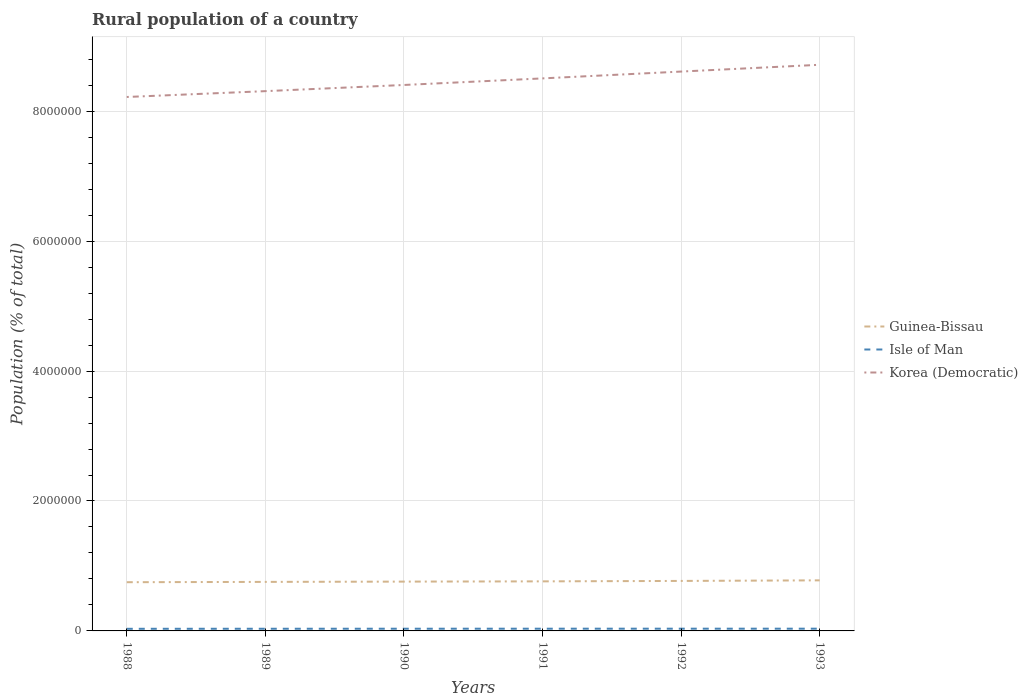How many different coloured lines are there?
Your answer should be very brief. 3. Is the number of lines equal to the number of legend labels?
Provide a succinct answer. Yes. Across all years, what is the maximum rural population in Guinea-Bissau?
Keep it short and to the point. 7.50e+05. What is the total rural population in Isle of Man in the graph?
Provide a succinct answer. -1722. What is the difference between the highest and the second highest rural population in Guinea-Bissau?
Make the answer very short. 2.86e+04. How many lines are there?
Give a very brief answer. 3. Does the graph contain any zero values?
Your response must be concise. No. Does the graph contain grids?
Ensure brevity in your answer.  Yes. Where does the legend appear in the graph?
Keep it short and to the point. Center right. How many legend labels are there?
Your answer should be compact. 3. How are the legend labels stacked?
Offer a terse response. Vertical. What is the title of the graph?
Your answer should be compact. Rural population of a country. What is the label or title of the Y-axis?
Your answer should be very brief. Population (% of total). What is the Population (% of total) of Guinea-Bissau in 1988?
Make the answer very short. 7.50e+05. What is the Population (% of total) in Isle of Man in 1988?
Give a very brief answer. 3.28e+04. What is the Population (% of total) in Korea (Democratic) in 1988?
Your answer should be compact. 8.22e+06. What is the Population (% of total) of Guinea-Bissau in 1989?
Offer a terse response. 7.55e+05. What is the Population (% of total) in Isle of Man in 1989?
Make the answer very short. 3.34e+04. What is the Population (% of total) of Korea (Democratic) in 1989?
Ensure brevity in your answer.  8.31e+06. What is the Population (% of total) in Guinea-Bissau in 1990?
Give a very brief answer. 7.59e+05. What is the Population (% of total) of Isle of Man in 1990?
Keep it short and to the point. 3.39e+04. What is the Population (% of total) of Korea (Democratic) in 1990?
Give a very brief answer. 8.40e+06. What is the Population (% of total) of Guinea-Bissau in 1991?
Keep it short and to the point. 7.63e+05. What is the Population (% of total) of Isle of Man in 1991?
Keep it short and to the point. 3.42e+04. What is the Population (% of total) of Korea (Democratic) in 1991?
Your answer should be very brief. 8.51e+06. What is the Population (% of total) of Guinea-Bissau in 1992?
Give a very brief answer. 7.70e+05. What is the Population (% of total) in Isle of Man in 1992?
Give a very brief answer. 3.44e+04. What is the Population (% of total) of Korea (Democratic) in 1992?
Ensure brevity in your answer.  8.61e+06. What is the Population (% of total) in Guinea-Bissau in 1993?
Give a very brief answer. 7.78e+05. What is the Population (% of total) of Isle of Man in 1993?
Keep it short and to the point. 3.45e+04. What is the Population (% of total) in Korea (Democratic) in 1993?
Offer a very short reply. 8.71e+06. Across all years, what is the maximum Population (% of total) in Guinea-Bissau?
Offer a terse response. 7.78e+05. Across all years, what is the maximum Population (% of total) in Isle of Man?
Provide a short and direct response. 3.45e+04. Across all years, what is the maximum Population (% of total) of Korea (Democratic)?
Provide a short and direct response. 8.71e+06. Across all years, what is the minimum Population (% of total) in Guinea-Bissau?
Keep it short and to the point. 7.50e+05. Across all years, what is the minimum Population (% of total) of Isle of Man?
Make the answer very short. 3.28e+04. Across all years, what is the minimum Population (% of total) in Korea (Democratic)?
Provide a short and direct response. 8.22e+06. What is the total Population (% of total) in Guinea-Bissau in the graph?
Provide a short and direct response. 4.57e+06. What is the total Population (% of total) of Isle of Man in the graph?
Your answer should be very brief. 2.03e+05. What is the total Population (% of total) in Korea (Democratic) in the graph?
Give a very brief answer. 5.08e+07. What is the difference between the Population (% of total) of Guinea-Bissau in 1988 and that in 1989?
Your answer should be compact. -4837. What is the difference between the Population (% of total) of Isle of Man in 1988 and that in 1989?
Your answer should be compact. -660. What is the difference between the Population (% of total) of Korea (Democratic) in 1988 and that in 1989?
Your answer should be very brief. -9.00e+04. What is the difference between the Population (% of total) in Guinea-Bissau in 1988 and that in 1990?
Ensure brevity in your answer.  -9186. What is the difference between the Population (% of total) of Isle of Man in 1988 and that in 1990?
Give a very brief answer. -1168. What is the difference between the Population (% of total) in Korea (Democratic) in 1988 and that in 1990?
Keep it short and to the point. -1.85e+05. What is the difference between the Population (% of total) in Guinea-Bissau in 1988 and that in 1991?
Offer a terse response. -1.30e+04. What is the difference between the Population (% of total) in Isle of Man in 1988 and that in 1991?
Offer a very short reply. -1483. What is the difference between the Population (% of total) of Korea (Democratic) in 1988 and that in 1991?
Offer a terse response. -2.86e+05. What is the difference between the Population (% of total) in Guinea-Bissau in 1988 and that in 1992?
Keep it short and to the point. -1.97e+04. What is the difference between the Population (% of total) in Isle of Man in 1988 and that in 1992?
Your response must be concise. -1642. What is the difference between the Population (% of total) of Korea (Democratic) in 1988 and that in 1992?
Offer a very short reply. -3.91e+05. What is the difference between the Population (% of total) in Guinea-Bissau in 1988 and that in 1993?
Ensure brevity in your answer.  -2.86e+04. What is the difference between the Population (% of total) in Isle of Man in 1988 and that in 1993?
Give a very brief answer. -1722. What is the difference between the Population (% of total) of Korea (Democratic) in 1988 and that in 1993?
Keep it short and to the point. -4.96e+05. What is the difference between the Population (% of total) of Guinea-Bissau in 1989 and that in 1990?
Your answer should be compact. -4349. What is the difference between the Population (% of total) of Isle of Man in 1989 and that in 1990?
Ensure brevity in your answer.  -508. What is the difference between the Population (% of total) in Korea (Democratic) in 1989 and that in 1990?
Offer a very short reply. -9.50e+04. What is the difference between the Population (% of total) of Guinea-Bissau in 1989 and that in 1991?
Make the answer very short. -8191. What is the difference between the Population (% of total) of Isle of Man in 1989 and that in 1991?
Provide a succinct answer. -823. What is the difference between the Population (% of total) in Korea (Democratic) in 1989 and that in 1991?
Offer a terse response. -1.96e+05. What is the difference between the Population (% of total) in Guinea-Bissau in 1989 and that in 1992?
Provide a short and direct response. -1.49e+04. What is the difference between the Population (% of total) of Isle of Man in 1989 and that in 1992?
Your response must be concise. -982. What is the difference between the Population (% of total) of Korea (Democratic) in 1989 and that in 1992?
Your response must be concise. -3.01e+05. What is the difference between the Population (% of total) of Guinea-Bissau in 1989 and that in 1993?
Give a very brief answer. -2.37e+04. What is the difference between the Population (% of total) of Isle of Man in 1989 and that in 1993?
Offer a very short reply. -1062. What is the difference between the Population (% of total) in Korea (Democratic) in 1989 and that in 1993?
Ensure brevity in your answer.  -4.06e+05. What is the difference between the Population (% of total) in Guinea-Bissau in 1990 and that in 1991?
Give a very brief answer. -3842. What is the difference between the Population (% of total) in Isle of Man in 1990 and that in 1991?
Keep it short and to the point. -315. What is the difference between the Population (% of total) of Korea (Democratic) in 1990 and that in 1991?
Provide a short and direct response. -1.01e+05. What is the difference between the Population (% of total) in Guinea-Bissau in 1990 and that in 1992?
Your answer should be very brief. -1.05e+04. What is the difference between the Population (% of total) of Isle of Man in 1990 and that in 1992?
Your answer should be compact. -474. What is the difference between the Population (% of total) in Korea (Democratic) in 1990 and that in 1992?
Your answer should be compact. -2.06e+05. What is the difference between the Population (% of total) in Guinea-Bissau in 1990 and that in 1993?
Make the answer very short. -1.94e+04. What is the difference between the Population (% of total) in Isle of Man in 1990 and that in 1993?
Offer a terse response. -554. What is the difference between the Population (% of total) of Korea (Democratic) in 1990 and that in 1993?
Provide a succinct answer. -3.11e+05. What is the difference between the Population (% of total) in Guinea-Bissau in 1991 and that in 1992?
Your response must be concise. -6667. What is the difference between the Population (% of total) of Isle of Man in 1991 and that in 1992?
Offer a terse response. -159. What is the difference between the Population (% of total) of Korea (Democratic) in 1991 and that in 1992?
Give a very brief answer. -1.05e+05. What is the difference between the Population (% of total) in Guinea-Bissau in 1991 and that in 1993?
Your response must be concise. -1.55e+04. What is the difference between the Population (% of total) of Isle of Man in 1991 and that in 1993?
Offer a terse response. -239. What is the difference between the Population (% of total) in Korea (Democratic) in 1991 and that in 1993?
Give a very brief answer. -2.10e+05. What is the difference between the Population (% of total) in Guinea-Bissau in 1992 and that in 1993?
Offer a very short reply. -8874. What is the difference between the Population (% of total) in Isle of Man in 1992 and that in 1993?
Offer a very short reply. -80. What is the difference between the Population (% of total) in Korea (Democratic) in 1992 and that in 1993?
Ensure brevity in your answer.  -1.04e+05. What is the difference between the Population (% of total) in Guinea-Bissau in 1988 and the Population (% of total) in Isle of Man in 1989?
Provide a short and direct response. 7.16e+05. What is the difference between the Population (% of total) in Guinea-Bissau in 1988 and the Population (% of total) in Korea (Democratic) in 1989?
Provide a short and direct response. -7.56e+06. What is the difference between the Population (% of total) of Isle of Man in 1988 and the Population (% of total) of Korea (Democratic) in 1989?
Give a very brief answer. -8.28e+06. What is the difference between the Population (% of total) of Guinea-Bissau in 1988 and the Population (% of total) of Isle of Man in 1990?
Provide a succinct answer. 7.16e+05. What is the difference between the Population (% of total) of Guinea-Bissau in 1988 and the Population (% of total) of Korea (Democratic) in 1990?
Ensure brevity in your answer.  -7.65e+06. What is the difference between the Population (% of total) of Isle of Man in 1988 and the Population (% of total) of Korea (Democratic) in 1990?
Make the answer very short. -8.37e+06. What is the difference between the Population (% of total) of Guinea-Bissau in 1988 and the Population (% of total) of Isle of Man in 1991?
Offer a very short reply. 7.16e+05. What is the difference between the Population (% of total) in Guinea-Bissau in 1988 and the Population (% of total) in Korea (Democratic) in 1991?
Provide a short and direct response. -7.76e+06. What is the difference between the Population (% of total) in Isle of Man in 1988 and the Population (% of total) in Korea (Democratic) in 1991?
Keep it short and to the point. -8.47e+06. What is the difference between the Population (% of total) in Guinea-Bissau in 1988 and the Population (% of total) in Isle of Man in 1992?
Make the answer very short. 7.15e+05. What is the difference between the Population (% of total) of Guinea-Bissau in 1988 and the Population (% of total) of Korea (Democratic) in 1992?
Your response must be concise. -7.86e+06. What is the difference between the Population (% of total) of Isle of Man in 1988 and the Population (% of total) of Korea (Democratic) in 1992?
Provide a succinct answer. -8.58e+06. What is the difference between the Population (% of total) in Guinea-Bissau in 1988 and the Population (% of total) in Isle of Man in 1993?
Keep it short and to the point. 7.15e+05. What is the difference between the Population (% of total) in Guinea-Bissau in 1988 and the Population (% of total) in Korea (Democratic) in 1993?
Offer a very short reply. -7.97e+06. What is the difference between the Population (% of total) in Isle of Man in 1988 and the Population (% of total) in Korea (Democratic) in 1993?
Your response must be concise. -8.68e+06. What is the difference between the Population (% of total) in Guinea-Bissau in 1989 and the Population (% of total) in Isle of Man in 1990?
Offer a very short reply. 7.21e+05. What is the difference between the Population (% of total) in Guinea-Bissau in 1989 and the Population (% of total) in Korea (Democratic) in 1990?
Make the answer very short. -7.65e+06. What is the difference between the Population (% of total) of Isle of Man in 1989 and the Population (% of total) of Korea (Democratic) in 1990?
Ensure brevity in your answer.  -8.37e+06. What is the difference between the Population (% of total) in Guinea-Bissau in 1989 and the Population (% of total) in Isle of Man in 1991?
Offer a very short reply. 7.20e+05. What is the difference between the Population (% of total) in Guinea-Bissau in 1989 and the Population (% of total) in Korea (Democratic) in 1991?
Make the answer very short. -7.75e+06. What is the difference between the Population (% of total) of Isle of Man in 1989 and the Population (% of total) of Korea (Democratic) in 1991?
Your answer should be very brief. -8.47e+06. What is the difference between the Population (% of total) of Guinea-Bissau in 1989 and the Population (% of total) of Isle of Man in 1992?
Provide a succinct answer. 7.20e+05. What is the difference between the Population (% of total) in Guinea-Bissau in 1989 and the Population (% of total) in Korea (Democratic) in 1992?
Offer a very short reply. -7.86e+06. What is the difference between the Population (% of total) of Isle of Man in 1989 and the Population (% of total) of Korea (Democratic) in 1992?
Offer a terse response. -8.58e+06. What is the difference between the Population (% of total) of Guinea-Bissau in 1989 and the Population (% of total) of Isle of Man in 1993?
Offer a very short reply. 7.20e+05. What is the difference between the Population (% of total) in Guinea-Bissau in 1989 and the Population (% of total) in Korea (Democratic) in 1993?
Provide a succinct answer. -7.96e+06. What is the difference between the Population (% of total) in Isle of Man in 1989 and the Population (% of total) in Korea (Democratic) in 1993?
Make the answer very short. -8.68e+06. What is the difference between the Population (% of total) in Guinea-Bissau in 1990 and the Population (% of total) in Isle of Man in 1991?
Provide a short and direct response. 7.25e+05. What is the difference between the Population (% of total) in Guinea-Bissau in 1990 and the Population (% of total) in Korea (Democratic) in 1991?
Keep it short and to the point. -7.75e+06. What is the difference between the Population (% of total) in Isle of Man in 1990 and the Population (% of total) in Korea (Democratic) in 1991?
Provide a succinct answer. -8.47e+06. What is the difference between the Population (% of total) of Guinea-Bissau in 1990 and the Population (% of total) of Isle of Man in 1992?
Your answer should be very brief. 7.25e+05. What is the difference between the Population (% of total) in Guinea-Bissau in 1990 and the Population (% of total) in Korea (Democratic) in 1992?
Your response must be concise. -7.85e+06. What is the difference between the Population (% of total) in Isle of Man in 1990 and the Population (% of total) in Korea (Democratic) in 1992?
Offer a very short reply. -8.58e+06. What is the difference between the Population (% of total) of Guinea-Bissau in 1990 and the Population (% of total) of Isle of Man in 1993?
Give a very brief answer. 7.25e+05. What is the difference between the Population (% of total) of Guinea-Bissau in 1990 and the Population (% of total) of Korea (Democratic) in 1993?
Provide a succinct answer. -7.96e+06. What is the difference between the Population (% of total) in Isle of Man in 1990 and the Population (% of total) in Korea (Democratic) in 1993?
Provide a short and direct response. -8.68e+06. What is the difference between the Population (% of total) of Guinea-Bissau in 1991 and the Population (% of total) of Isle of Man in 1992?
Your answer should be very brief. 7.29e+05. What is the difference between the Population (% of total) in Guinea-Bissau in 1991 and the Population (% of total) in Korea (Democratic) in 1992?
Your response must be concise. -7.85e+06. What is the difference between the Population (% of total) of Isle of Man in 1991 and the Population (% of total) of Korea (Democratic) in 1992?
Your answer should be compact. -8.58e+06. What is the difference between the Population (% of total) of Guinea-Bissau in 1991 and the Population (% of total) of Isle of Man in 1993?
Provide a succinct answer. 7.28e+05. What is the difference between the Population (% of total) in Guinea-Bissau in 1991 and the Population (% of total) in Korea (Democratic) in 1993?
Offer a very short reply. -7.95e+06. What is the difference between the Population (% of total) in Isle of Man in 1991 and the Population (% of total) in Korea (Democratic) in 1993?
Offer a terse response. -8.68e+06. What is the difference between the Population (% of total) in Guinea-Bissau in 1992 and the Population (% of total) in Isle of Man in 1993?
Make the answer very short. 7.35e+05. What is the difference between the Population (% of total) in Guinea-Bissau in 1992 and the Population (% of total) in Korea (Democratic) in 1993?
Make the answer very short. -7.95e+06. What is the difference between the Population (% of total) of Isle of Man in 1992 and the Population (% of total) of Korea (Democratic) in 1993?
Offer a very short reply. -8.68e+06. What is the average Population (% of total) in Guinea-Bissau per year?
Provide a short and direct response. 7.62e+05. What is the average Population (% of total) of Isle of Man per year?
Give a very brief answer. 3.39e+04. What is the average Population (% of total) in Korea (Democratic) per year?
Provide a succinct answer. 8.46e+06. In the year 1988, what is the difference between the Population (% of total) of Guinea-Bissau and Population (% of total) of Isle of Man?
Your response must be concise. 7.17e+05. In the year 1988, what is the difference between the Population (% of total) in Guinea-Bissau and Population (% of total) in Korea (Democratic)?
Offer a terse response. -7.47e+06. In the year 1988, what is the difference between the Population (% of total) of Isle of Man and Population (% of total) of Korea (Democratic)?
Offer a very short reply. -8.19e+06. In the year 1989, what is the difference between the Population (% of total) of Guinea-Bissau and Population (% of total) of Isle of Man?
Give a very brief answer. 7.21e+05. In the year 1989, what is the difference between the Population (% of total) of Guinea-Bissau and Population (% of total) of Korea (Democratic)?
Your answer should be very brief. -7.55e+06. In the year 1989, what is the difference between the Population (% of total) in Isle of Man and Population (% of total) in Korea (Democratic)?
Ensure brevity in your answer.  -8.28e+06. In the year 1990, what is the difference between the Population (% of total) in Guinea-Bissau and Population (% of total) in Isle of Man?
Keep it short and to the point. 7.25e+05. In the year 1990, what is the difference between the Population (% of total) in Guinea-Bissau and Population (% of total) in Korea (Democratic)?
Offer a very short reply. -7.64e+06. In the year 1990, what is the difference between the Population (% of total) of Isle of Man and Population (% of total) of Korea (Democratic)?
Your response must be concise. -8.37e+06. In the year 1991, what is the difference between the Population (% of total) of Guinea-Bissau and Population (% of total) of Isle of Man?
Give a very brief answer. 7.29e+05. In the year 1991, what is the difference between the Population (% of total) of Guinea-Bissau and Population (% of total) of Korea (Democratic)?
Provide a succinct answer. -7.74e+06. In the year 1991, what is the difference between the Population (% of total) in Isle of Man and Population (% of total) in Korea (Democratic)?
Your answer should be compact. -8.47e+06. In the year 1992, what is the difference between the Population (% of total) of Guinea-Bissau and Population (% of total) of Isle of Man?
Your response must be concise. 7.35e+05. In the year 1992, what is the difference between the Population (% of total) in Guinea-Bissau and Population (% of total) in Korea (Democratic)?
Provide a short and direct response. -7.84e+06. In the year 1992, what is the difference between the Population (% of total) of Isle of Man and Population (% of total) of Korea (Democratic)?
Your answer should be very brief. -8.58e+06. In the year 1993, what is the difference between the Population (% of total) of Guinea-Bissau and Population (% of total) of Isle of Man?
Your answer should be very brief. 7.44e+05. In the year 1993, what is the difference between the Population (% of total) in Guinea-Bissau and Population (% of total) in Korea (Democratic)?
Offer a very short reply. -7.94e+06. In the year 1993, what is the difference between the Population (% of total) in Isle of Man and Population (% of total) in Korea (Democratic)?
Offer a terse response. -8.68e+06. What is the ratio of the Population (% of total) of Isle of Man in 1988 to that in 1989?
Provide a short and direct response. 0.98. What is the ratio of the Population (% of total) of Guinea-Bissau in 1988 to that in 1990?
Keep it short and to the point. 0.99. What is the ratio of the Population (% of total) of Isle of Man in 1988 to that in 1990?
Give a very brief answer. 0.97. What is the ratio of the Population (% of total) in Guinea-Bissau in 1988 to that in 1991?
Make the answer very short. 0.98. What is the ratio of the Population (% of total) of Isle of Man in 1988 to that in 1991?
Offer a very short reply. 0.96. What is the ratio of the Population (% of total) in Korea (Democratic) in 1988 to that in 1991?
Your answer should be very brief. 0.97. What is the ratio of the Population (% of total) of Guinea-Bissau in 1988 to that in 1992?
Your answer should be very brief. 0.97. What is the ratio of the Population (% of total) in Isle of Man in 1988 to that in 1992?
Give a very brief answer. 0.95. What is the ratio of the Population (% of total) of Korea (Democratic) in 1988 to that in 1992?
Make the answer very short. 0.95. What is the ratio of the Population (% of total) of Guinea-Bissau in 1988 to that in 1993?
Keep it short and to the point. 0.96. What is the ratio of the Population (% of total) in Isle of Man in 1988 to that in 1993?
Offer a very short reply. 0.95. What is the ratio of the Population (% of total) of Korea (Democratic) in 1988 to that in 1993?
Provide a short and direct response. 0.94. What is the ratio of the Population (% of total) of Korea (Democratic) in 1989 to that in 1990?
Give a very brief answer. 0.99. What is the ratio of the Population (% of total) in Guinea-Bissau in 1989 to that in 1991?
Provide a short and direct response. 0.99. What is the ratio of the Population (% of total) in Isle of Man in 1989 to that in 1991?
Offer a very short reply. 0.98. What is the ratio of the Population (% of total) in Korea (Democratic) in 1989 to that in 1991?
Ensure brevity in your answer.  0.98. What is the ratio of the Population (% of total) of Guinea-Bissau in 1989 to that in 1992?
Offer a very short reply. 0.98. What is the ratio of the Population (% of total) in Isle of Man in 1989 to that in 1992?
Make the answer very short. 0.97. What is the ratio of the Population (% of total) in Korea (Democratic) in 1989 to that in 1992?
Provide a short and direct response. 0.96. What is the ratio of the Population (% of total) in Guinea-Bissau in 1989 to that in 1993?
Make the answer very short. 0.97. What is the ratio of the Population (% of total) of Isle of Man in 1989 to that in 1993?
Your response must be concise. 0.97. What is the ratio of the Population (% of total) in Korea (Democratic) in 1989 to that in 1993?
Provide a succinct answer. 0.95. What is the ratio of the Population (% of total) of Isle of Man in 1990 to that in 1991?
Offer a very short reply. 0.99. What is the ratio of the Population (% of total) in Korea (Democratic) in 1990 to that in 1991?
Keep it short and to the point. 0.99. What is the ratio of the Population (% of total) in Guinea-Bissau in 1990 to that in 1992?
Your answer should be very brief. 0.99. What is the ratio of the Population (% of total) in Isle of Man in 1990 to that in 1992?
Your answer should be compact. 0.99. What is the ratio of the Population (% of total) in Korea (Democratic) in 1990 to that in 1992?
Offer a terse response. 0.98. What is the ratio of the Population (% of total) in Guinea-Bissau in 1990 to that in 1993?
Offer a terse response. 0.98. What is the ratio of the Population (% of total) in Isle of Man in 1990 to that in 1993?
Provide a short and direct response. 0.98. What is the ratio of the Population (% of total) of Korea (Democratic) in 1990 to that in 1993?
Offer a terse response. 0.96. What is the ratio of the Population (% of total) in Guinea-Bissau in 1991 to that in 1992?
Make the answer very short. 0.99. What is the ratio of the Population (% of total) of Isle of Man in 1991 to that in 1992?
Your response must be concise. 1. What is the ratio of the Population (% of total) of Isle of Man in 1991 to that in 1993?
Give a very brief answer. 0.99. What is the ratio of the Population (% of total) in Korea (Democratic) in 1991 to that in 1993?
Keep it short and to the point. 0.98. What is the difference between the highest and the second highest Population (% of total) of Guinea-Bissau?
Your response must be concise. 8874. What is the difference between the highest and the second highest Population (% of total) in Isle of Man?
Your response must be concise. 80. What is the difference between the highest and the second highest Population (% of total) in Korea (Democratic)?
Your answer should be very brief. 1.04e+05. What is the difference between the highest and the lowest Population (% of total) in Guinea-Bissau?
Offer a terse response. 2.86e+04. What is the difference between the highest and the lowest Population (% of total) in Isle of Man?
Offer a terse response. 1722. What is the difference between the highest and the lowest Population (% of total) of Korea (Democratic)?
Keep it short and to the point. 4.96e+05. 